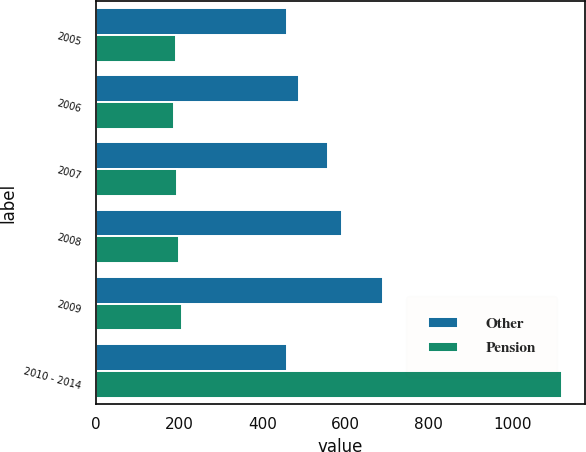Convert chart. <chart><loc_0><loc_0><loc_500><loc_500><stacked_bar_chart><ecel><fcel>2005<fcel>2006<fcel>2007<fcel>2008<fcel>2009<fcel>2010 - 2014<nl><fcel>Other<fcel>460<fcel>488<fcel>557<fcel>591<fcel>690<fcel>460<nl><fcel>Pension<fcel>193<fcel>187<fcel>195<fcel>201<fcel>208<fcel>1119<nl></chart> 